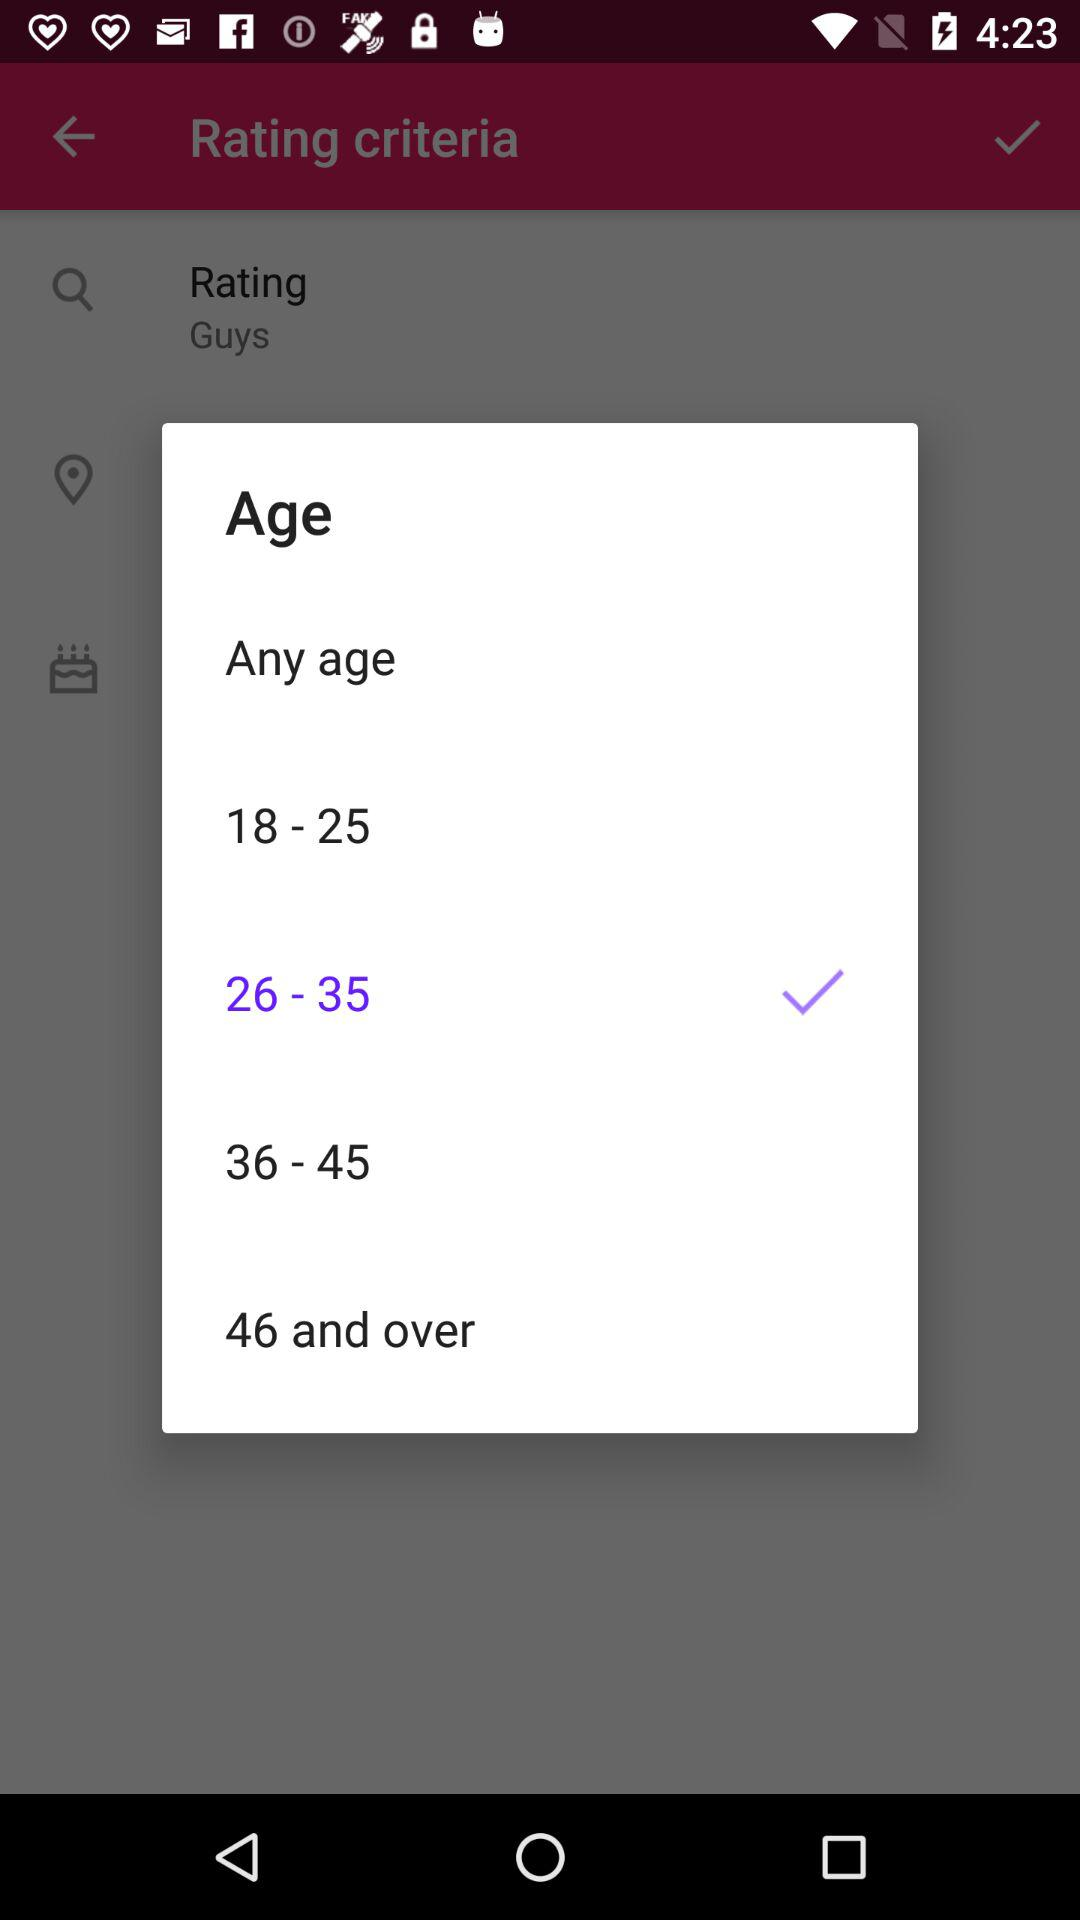Which is the selected age range? The selected age range is between 26 and 35. 